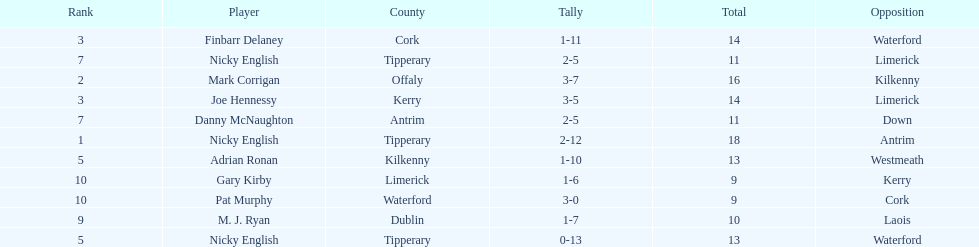What is the least total on the list? 9. Could you help me parse every detail presented in this table? {'header': ['Rank', 'Player', 'County', 'Tally', 'Total', 'Opposition'], 'rows': [['3', 'Finbarr Delaney', 'Cork', '1-11', '14', 'Waterford'], ['7', 'Nicky English', 'Tipperary', '2-5', '11', 'Limerick'], ['2', 'Mark Corrigan', 'Offaly', '3-7', '16', 'Kilkenny'], ['3', 'Joe Hennessy', 'Kerry', '3-5', '14', 'Limerick'], ['7', 'Danny McNaughton', 'Antrim', '2-5', '11', 'Down'], ['1', 'Nicky English', 'Tipperary', '2-12', '18', 'Antrim'], ['5', 'Adrian Ronan', 'Kilkenny', '1-10', '13', 'Westmeath'], ['10', 'Gary Kirby', 'Limerick', '1-6', '9', 'Kerry'], ['10', 'Pat Murphy', 'Waterford', '3-0', '9', 'Cork'], ['9', 'M. J. Ryan', 'Dublin', '1-7', '10', 'Laois'], ['5', 'Nicky English', 'Tipperary', '0-13', '13', 'Waterford']]} 